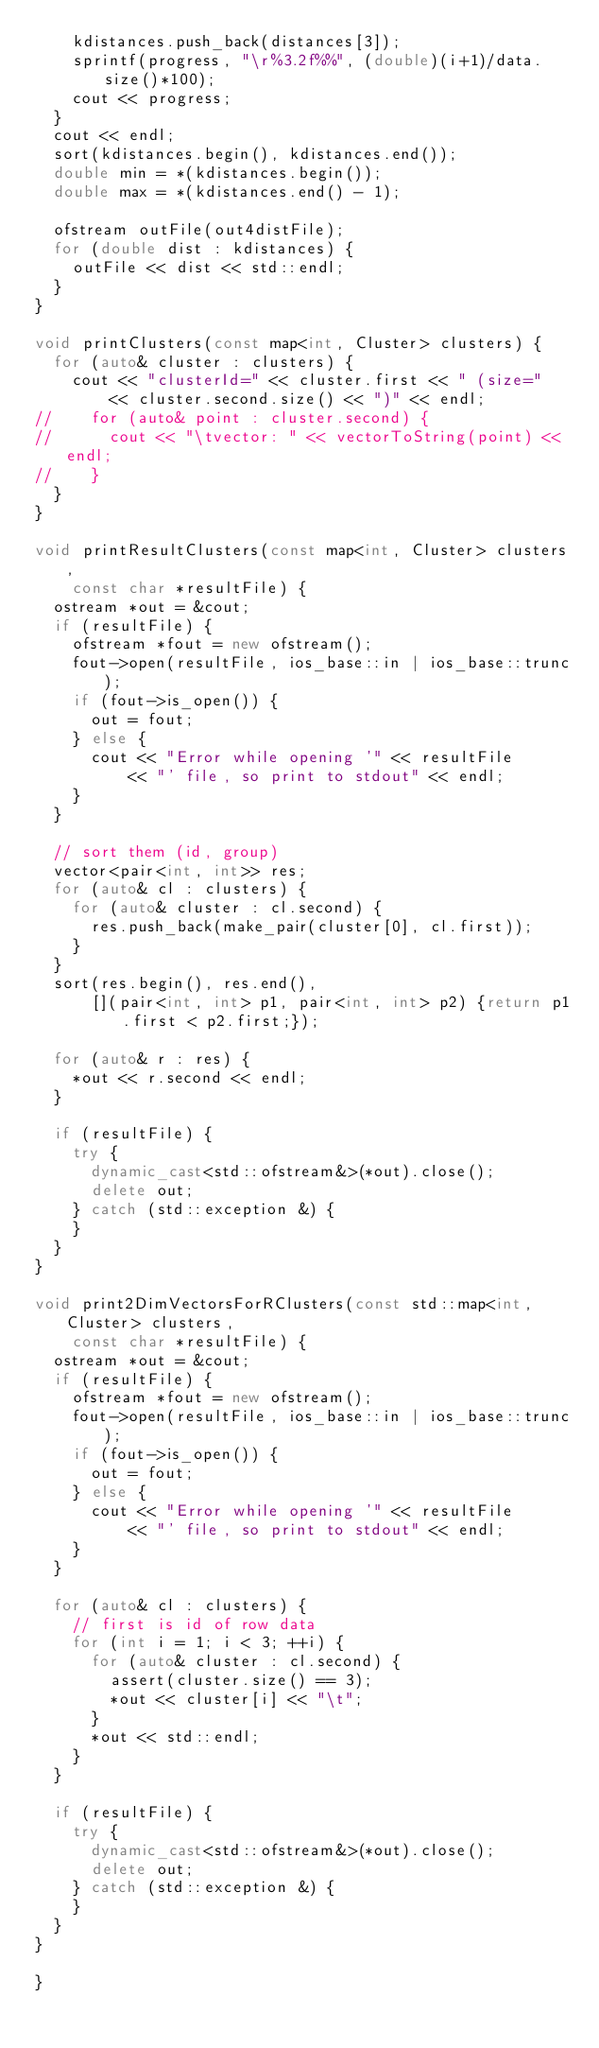Convert code to text. <code><loc_0><loc_0><loc_500><loc_500><_C++_>		kdistances.push_back(distances[3]);
		sprintf(progress, "\r%3.2f%%", (double)(i+1)/data.size()*100);
		cout << progress;	
	}
	cout << endl;
	sort(kdistances.begin(), kdistances.end());
	double min = *(kdistances.begin());
	double max = *(kdistances.end() - 1);

	ofstream outFile(out4distFile);
	for (double dist : kdistances) {
		outFile << dist << std::endl;
	}
}

void printClusters(const map<int, Cluster> clusters) {
	for (auto& cluster : clusters) {
		cout << "clusterId=" << cluster.first << " (size="
				<< cluster.second.size() << ")" << endl;
//		for (auto& point : cluster.second) {
//			cout << "\tvector: " << vectorToString(point) << endl;
//		}
	}
}

void printResultClusters(const map<int, Cluster> clusters,
		const char *resultFile) {
	ostream *out = &cout;
	if (resultFile) {
		ofstream *fout = new ofstream();
		fout->open(resultFile, ios_base::in | ios_base::trunc);
		if (fout->is_open()) {
			out = fout;
		} else {
			cout << "Error while opening '" << resultFile
					<< "' file, so print to stdout" << endl;
		}
	}

	// sort them (id, group)
	vector<pair<int, int>> res;
	for (auto& cl : clusters) {
		for (auto& cluster : cl.second) {
			res.push_back(make_pair(cluster[0], cl.first));
		}
	}
	sort(res.begin(), res.end(),
			[](pair<int, int> p1, pair<int, int> p2) {return p1.first < p2.first;});

	for (auto& r : res) {
		*out << r.second << endl;
	}

	if (resultFile) {
		try {
			dynamic_cast<std::ofstream&>(*out).close();
			delete out;
		} catch (std::exception &) {
		}
	}
}

void print2DimVectorsForRClusters(const std::map<int, Cluster> clusters,
		const char *resultFile) {
	ostream *out = &cout;
	if (resultFile) {
		ofstream *fout = new ofstream();
		fout->open(resultFile, ios_base::in | ios_base::trunc);
		if (fout->is_open()) {
			out = fout;
		} else {
			cout << "Error while opening '" << resultFile
					<< "' file, so print to stdout" << endl;
		}
	}

	for (auto& cl : clusters) {
		// first is id of row data
		for (int i = 1; i < 3; ++i) {
			for (auto& cluster : cl.second) {
				assert(cluster.size() == 3);
				*out << cluster[i] << "\t";
			}
			*out << std::endl;
		}
	}

	if (resultFile) {
		try {
			dynamic_cast<std::ofstream&>(*out).close();
			delete out;
		} catch (std::exception &) {
		}
	}
}

}
</code> 